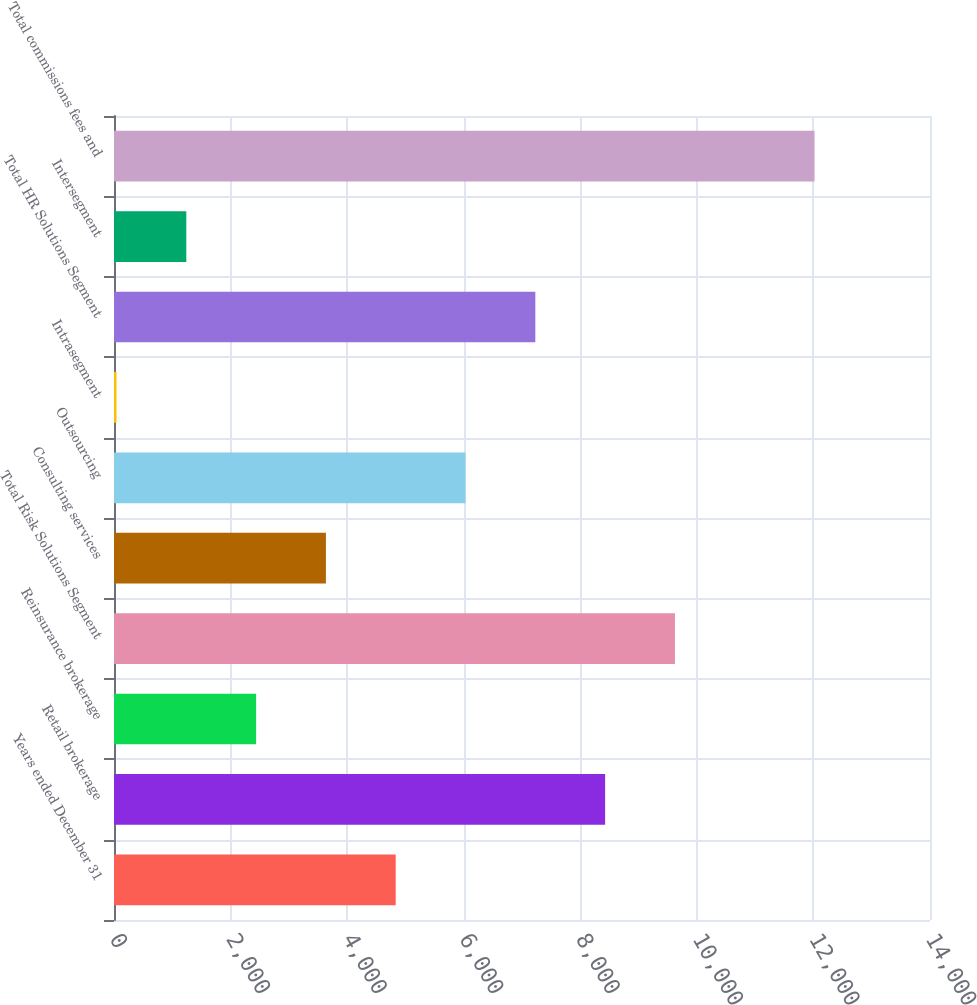Convert chart to OTSL. <chart><loc_0><loc_0><loc_500><loc_500><bar_chart><fcel>Years ended December 31<fcel>Retail brokerage<fcel>Reinsurance brokerage<fcel>Total Risk Solutions Segment<fcel>Consulting services<fcel>Outsourcing<fcel>Intrasegment<fcel>Total HR Solutions Segment<fcel>Intersegment<fcel>Total commissions fees and<nl><fcel>4833.4<fcel>8426.2<fcel>2438.2<fcel>9623.8<fcel>3635.8<fcel>6031<fcel>43<fcel>7228.6<fcel>1240.6<fcel>12019<nl></chart> 